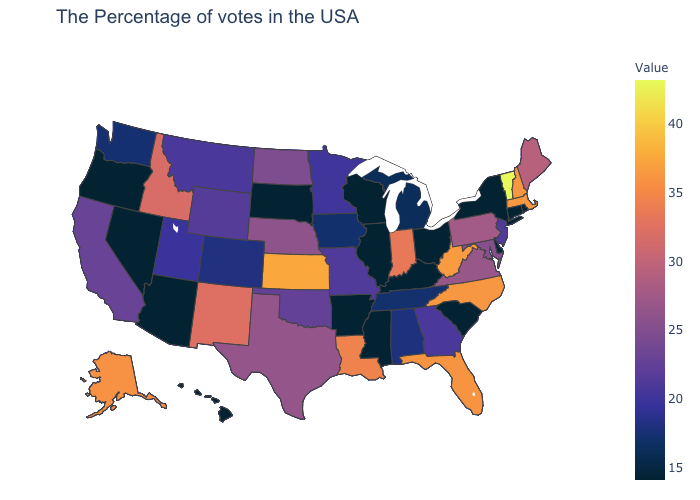Among the states that border Illinois , which have the highest value?
Be succinct. Indiana. Does Nevada have the lowest value in the USA?
Give a very brief answer. Yes. Among the states that border Wyoming , which have the highest value?
Concise answer only. Idaho. 